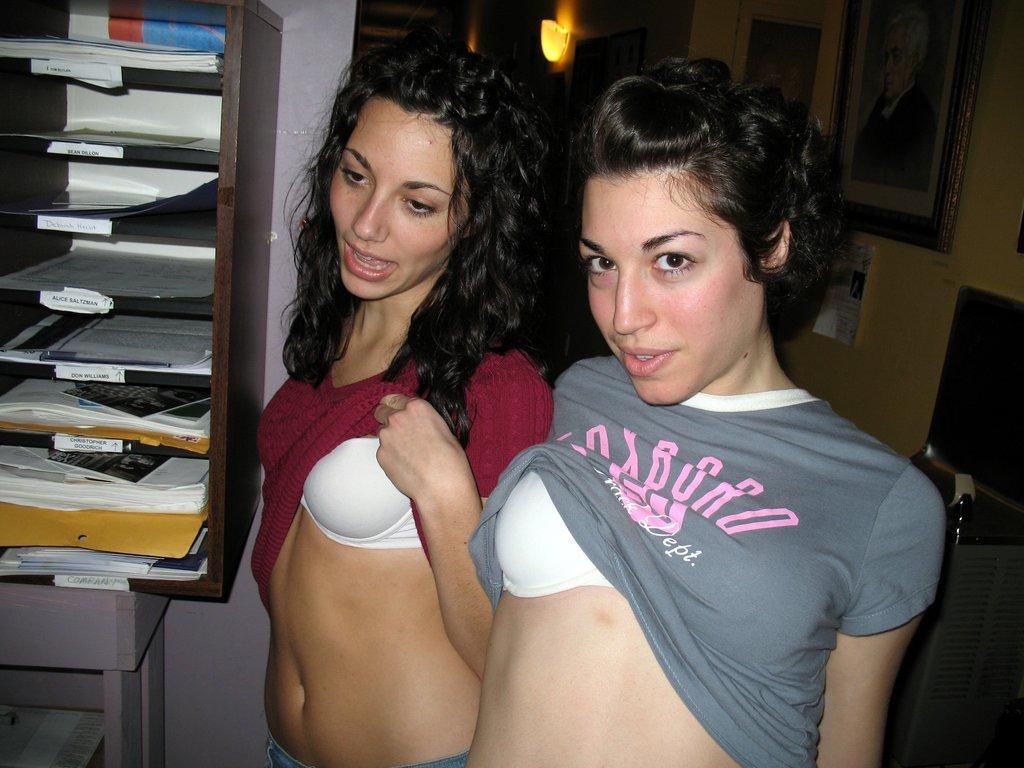<image>
Share a concise interpretation of the image provided. two girls pulling their shirts up passed their bras with a stack of mailboxes behidn them with one labeled don williams 